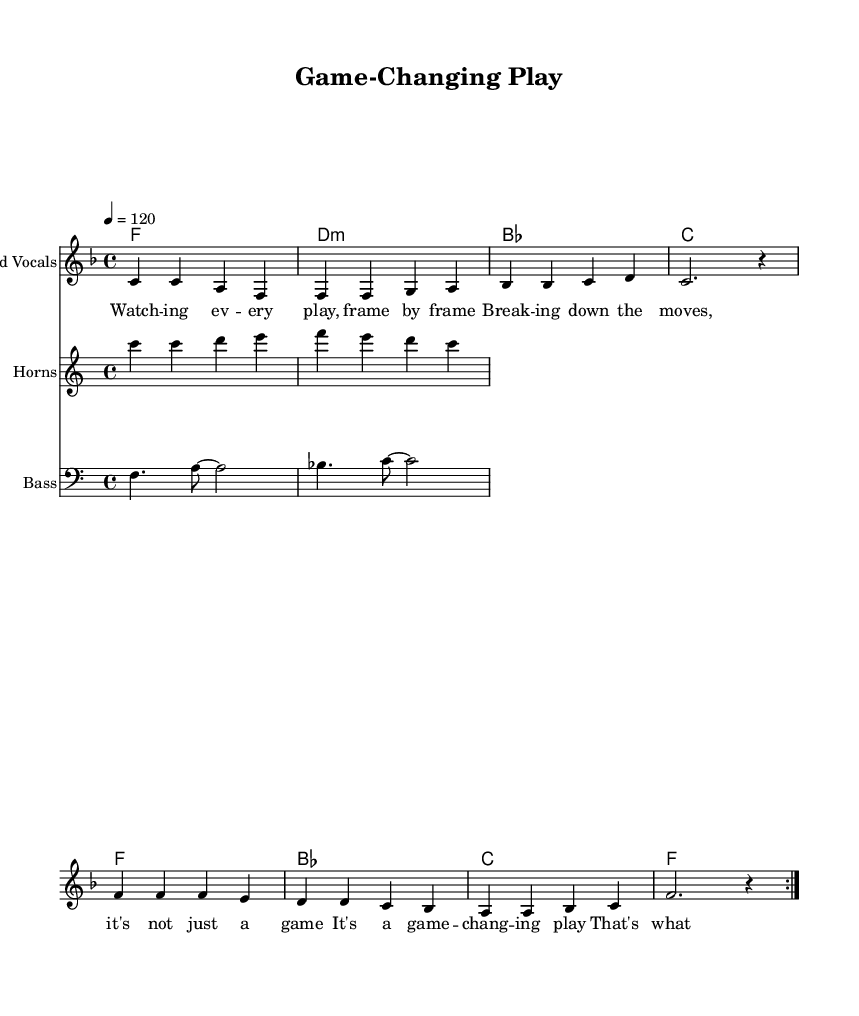What is the key signature of this music? The key signature is F major, which has one flat (B flat). This can be determined by examining the key signature indicated at the beginning of the score.
Answer: F major What is the time signature of this piece? The time signature is 4/4, indicated at the beginning of the piece. This means there are four beats in each measure, and the quarter note receives one beat.
Answer: 4/4 What is the tempo marking given in this score? The tempo marking is 120 beats per minute, indicated in the tempo instruction at the beginning of the piece. This specifies how fast the music should be played.
Answer: 120 How many times is the melody repeated? The melody is repeated two times, as indicated by the "volta" markings in the score that show it is to be played twice.
Answer: 2 What musical style does this piece belong to? This piece belongs to the soul genre, characterized by its strong focus on rhythm, emotion, and often relates to themes of life experiences, such as sports analysis in this context.
Answer: Soul Which instruments are featured in this score? The score features lead vocals, horns, and bass, as specified by the different staff headings in the score. Each instrument is clearly labeled at the beginning of its respective staff.
Answer: Lead Vocals, Horns, Bass What is the overall theme conveyed in the lyrics? The overall theme conveyed in the lyrics centers around analyzing plays in sports, emphasizing a focus on breaking down movements and highlighting game-changing moments. The lyrics express enthusiasm for this analytical approach.
Answer: Analyzing sports plays 